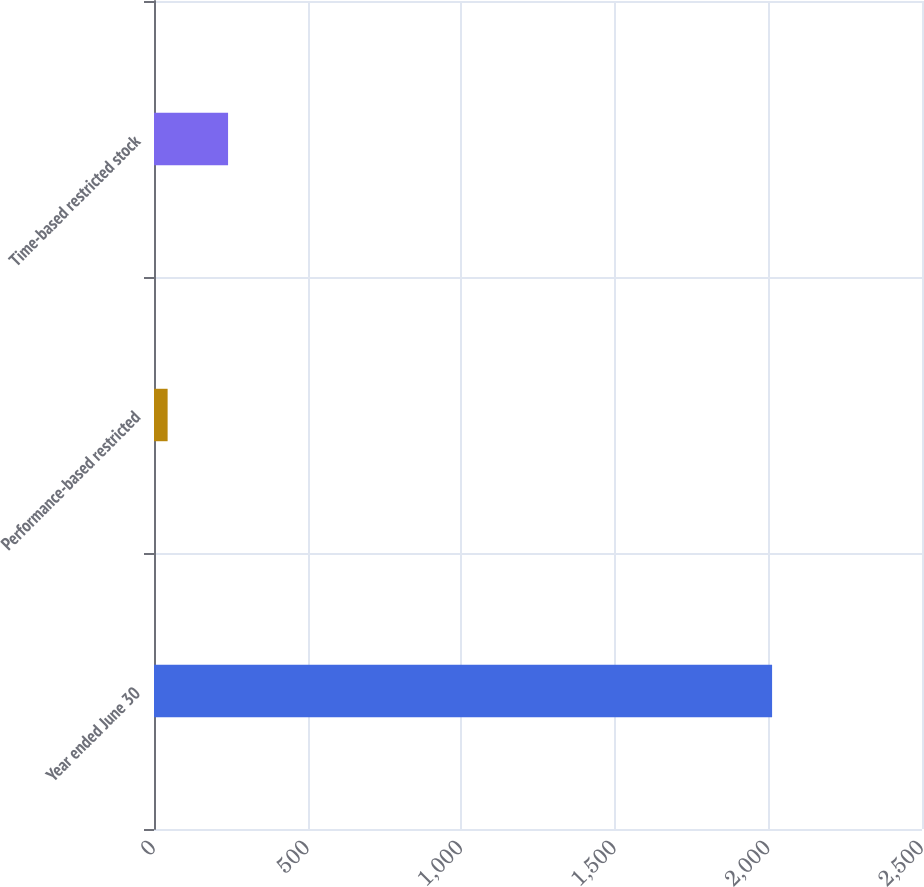<chart> <loc_0><loc_0><loc_500><loc_500><bar_chart><fcel>Year ended June 30<fcel>Performance-based restricted<fcel>Time-based restricted stock<nl><fcel>2012<fcel>44.33<fcel>241.1<nl></chart> 